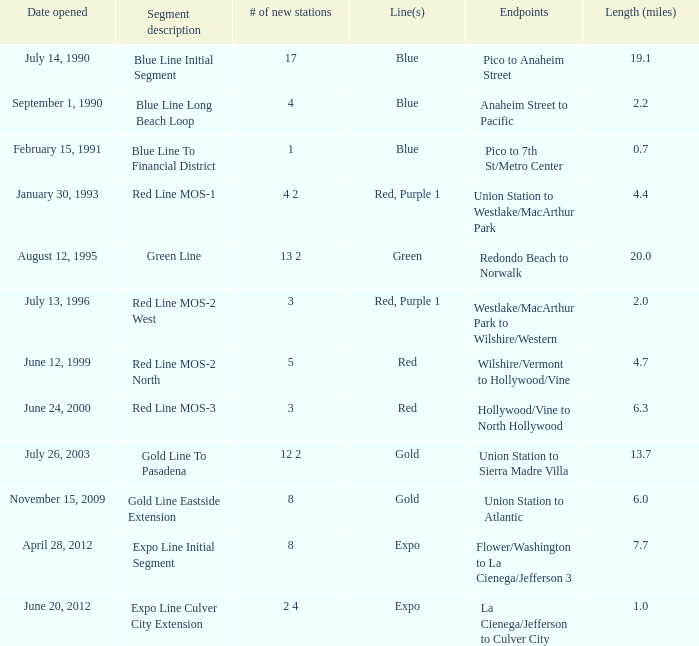How many news stations opened on the date of June 24, 2000? 3.0. 